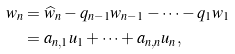<formula> <loc_0><loc_0><loc_500><loc_500>w _ { n } & = \widehat { w } _ { n } - q _ { n - 1 } w _ { n - 1 } - \cdots - q _ { 1 } w _ { 1 } \\ & = a _ { n , 1 } u _ { 1 } + \cdots + a _ { n , n } u _ { n } , \\</formula> 